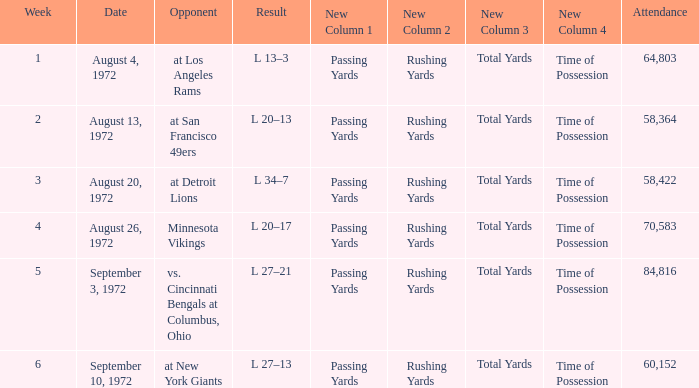Parse the full table. {'header': ['Week', 'Date', 'Opponent', 'Result', 'New Column 1', 'New Column 2', 'New Column 3', 'New Column 4', 'Attendance'], 'rows': [['1', 'August 4, 1972', 'at Los Angeles Rams', 'L 13–3', 'Passing Yards', 'Rushing Yards', 'Total Yards', 'Time of Possession', '64,803'], ['2', 'August 13, 1972', 'at San Francisco 49ers', 'L 20–13', 'Passing Yards', 'Rushing Yards', 'Total Yards', 'Time of Possession', '58,364'], ['3', 'August 20, 1972', 'at Detroit Lions', 'L 34–7', 'Passing Yards', 'Rushing Yards', 'Total Yards', 'Time of Possession', '58,422'], ['4', 'August 26, 1972', 'Minnesota Vikings', 'L 20–17', 'Passing Yards', 'Rushing Yards', 'Total Yards', 'Time of Possession', '70,583'], ['5', 'September 3, 1972', 'vs. Cincinnati Bengals at Columbus, Ohio', 'L 27–21', 'Passing Yards', 'Rushing Yards', 'Total Yards', 'Time of Possession', '84,816'], ['6', 'September 10, 1972', 'at New York Giants', 'L 27–13', 'Passing Yards', 'Rushing Yards', 'Total Yards', 'Time of Possession', '60,152']]} What is the lowest attendance on September 3, 1972? 84816.0. 